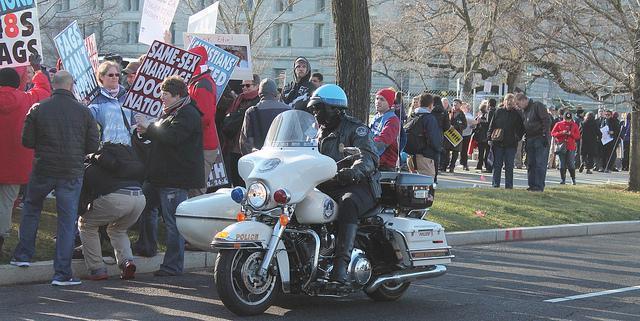What sort of sex is everyone here thinking about?
From the following four choices, select the correct answer to address the question.
Options: Straight, gay, bondage only, none. Gay. 